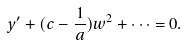<formula> <loc_0><loc_0><loc_500><loc_500>y ^ { \prime } + ( c - \frac { 1 } { a } ) w ^ { 2 } + \cdots = 0 .</formula> 